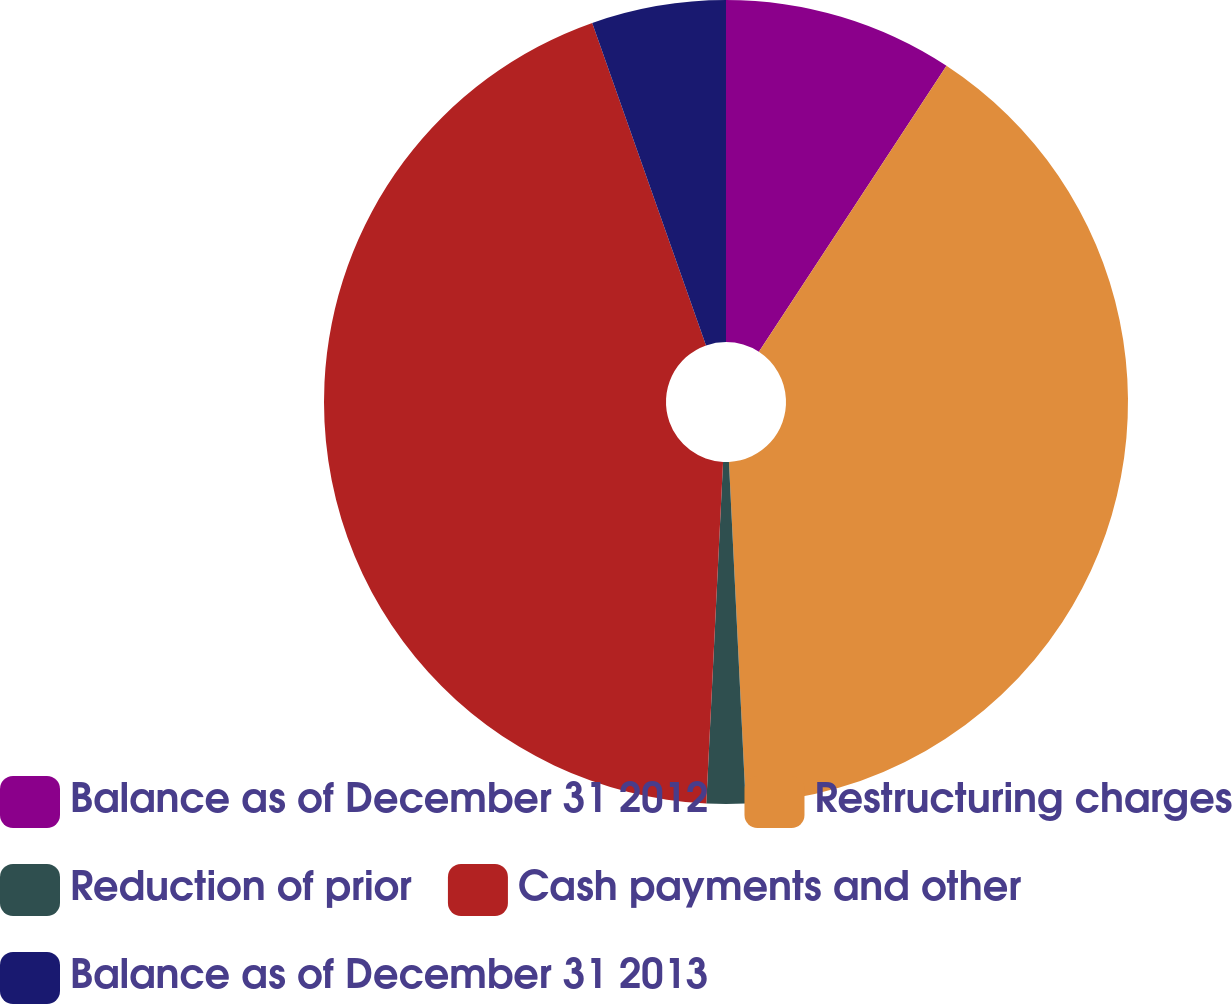<chart> <loc_0><loc_0><loc_500><loc_500><pie_chart><fcel>Balance as of December 31 2012<fcel>Restructuring charges<fcel>Reduction of prior<fcel>Cash payments and other<fcel>Balance as of December 31 2013<nl><fcel>9.24%<fcel>39.98%<fcel>1.56%<fcel>43.82%<fcel>5.4%<nl></chart> 